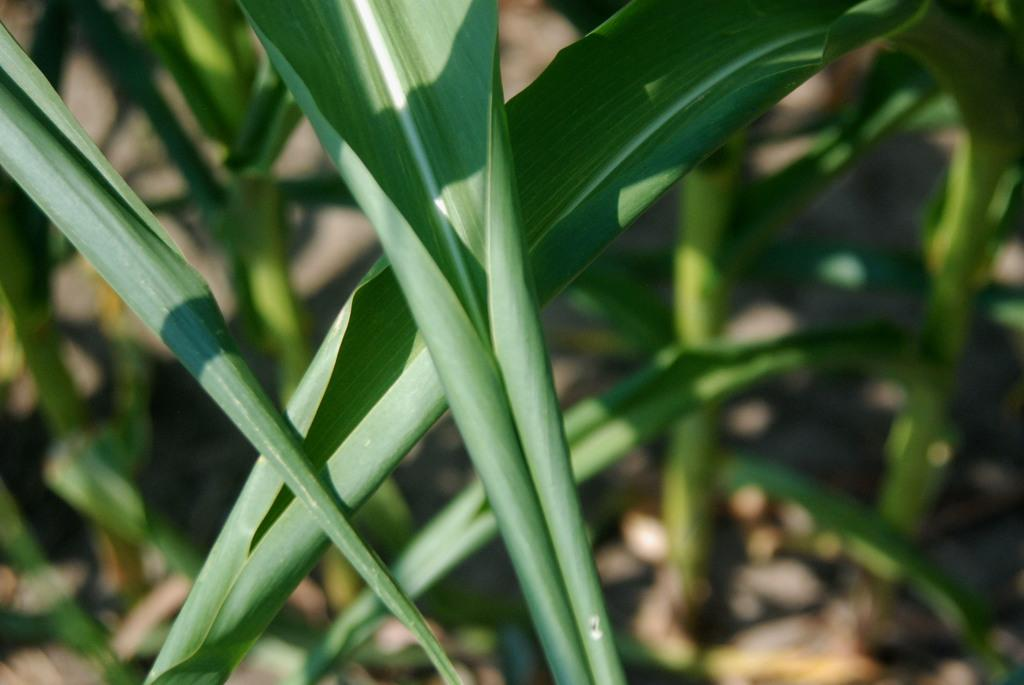What is visible in the foreground of the image? There are leafs in the foreground of the image. What can be seen in the background of the image? There are plants on the ground in the background of the image. What type of engine can be seen in the image? There is no engine present in the image; it features leafs in the foreground and plants in the background. How does the mist affect the visibility of the plants in the image? There is no mist present in the image, so it does not affect the visibility of the plants. 